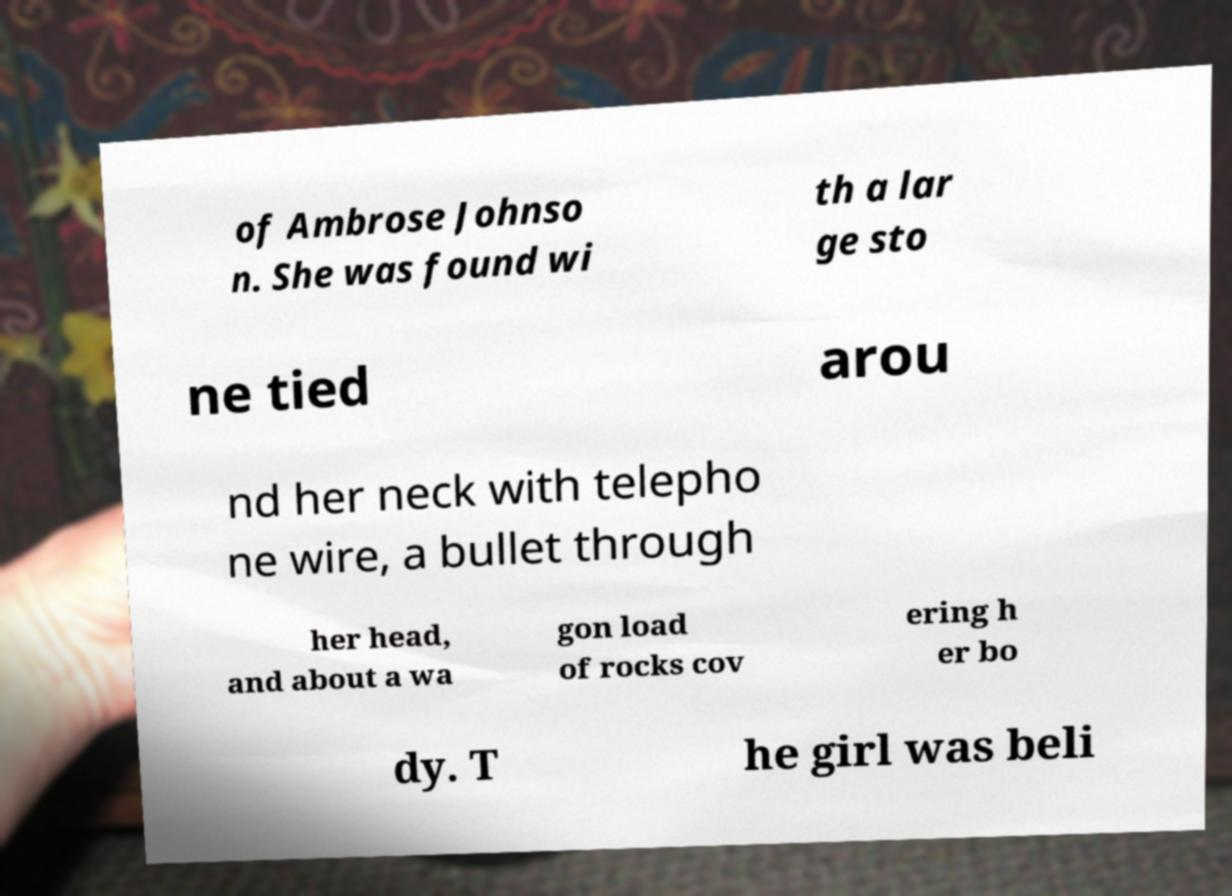Please identify and transcribe the text found in this image. of Ambrose Johnso n. She was found wi th a lar ge sto ne tied arou nd her neck with telepho ne wire, a bullet through her head, and about a wa gon load of rocks cov ering h er bo dy. T he girl was beli 